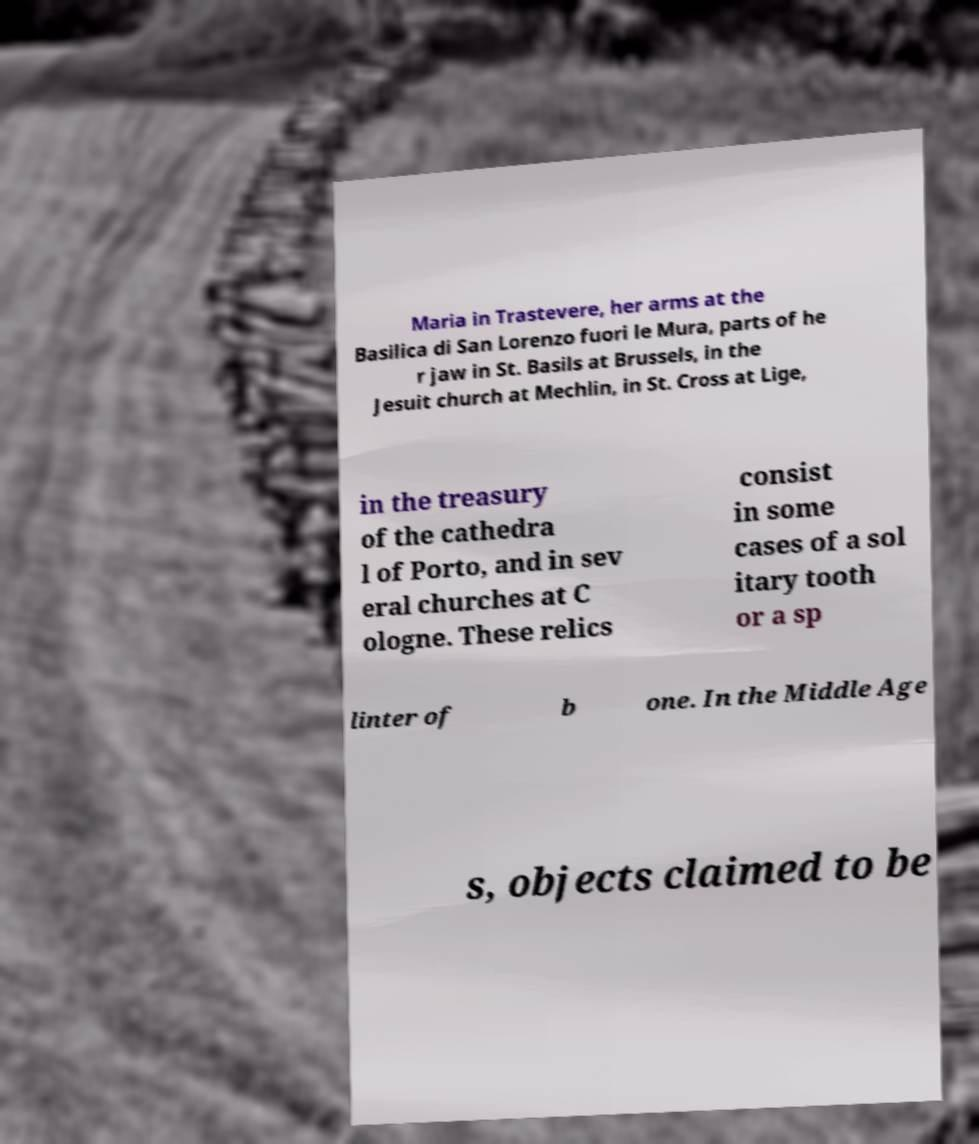Can you accurately transcribe the text from the provided image for me? Maria in Trastevere, her arms at the Basilica di San Lorenzo fuori le Mura, parts of he r jaw in St. Basils at Brussels, in the Jesuit church at Mechlin, in St. Cross at Lige, in the treasury of the cathedra l of Porto, and in sev eral churches at C ologne. These relics consist in some cases of a sol itary tooth or a sp linter of b one. In the Middle Age s, objects claimed to be 